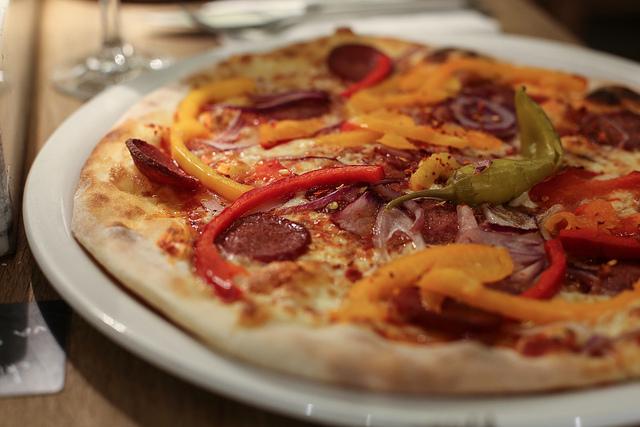Is there any meat on this pizza?
Be succinct. Yes. What ingredient is red on the pizza?
Short answer required. Bell pepper. Can you see pepperoni?
Be succinct. Yes. Would a vegetarian like this meal?
Write a very short answer. No. What is on the plate?
Answer briefly. Pizza. Is this homemade?
Be succinct. Yes. Is this a healthy meal?
Concise answer only. No. Are there mushrooms on the pizza?
Give a very brief answer. No. Are there peppers on the pizza?
Answer briefly. Yes. What kind of melted cheese is that?
Be succinct. Mozzarella. What is the green stuff on top of the pizza?
Answer briefly. Pepper. 